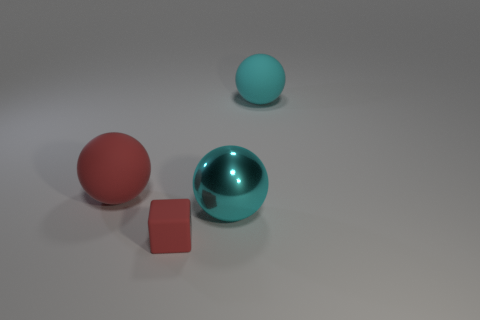Subtract 1 balls. How many balls are left? 2 Add 1 cyan rubber objects. How many objects exist? 5 Subtract all balls. How many objects are left? 1 Add 4 red balls. How many red balls exist? 5 Subtract 0 cyan cylinders. How many objects are left? 4 Subtract all metal spheres. Subtract all gray cubes. How many objects are left? 3 Add 2 big rubber objects. How many big rubber objects are left? 4 